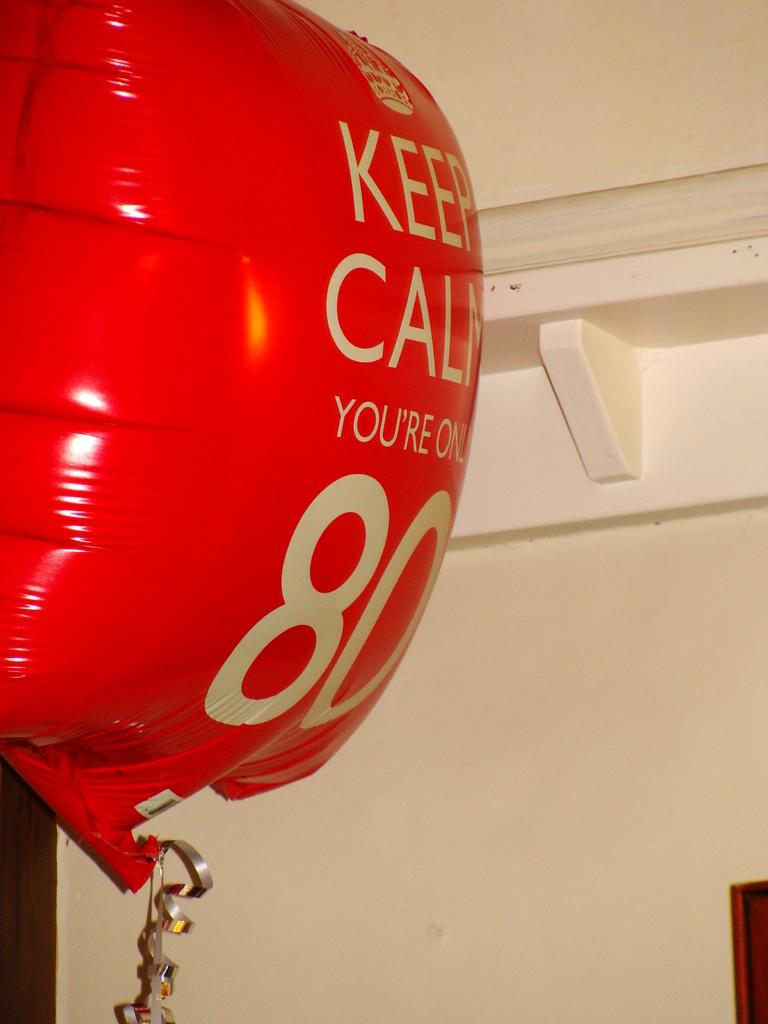Provide a one-sentence caption for the provided image. A red helium balloon that says keep calm, your'e only 80. 